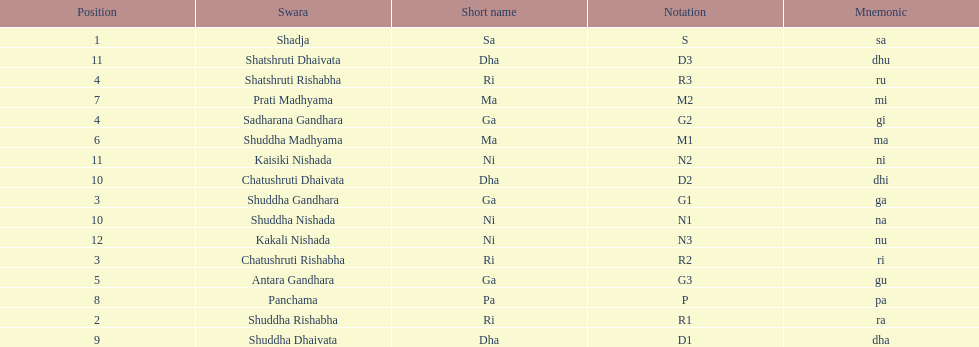List each pair of swaras that share the same position. Chatushruti Rishabha, Shuddha Gandhara, Shatshruti Rishabha, Sadharana Gandhara, Chatushruti Dhaivata, Shuddha Nishada, Shatshruti Dhaivata, Kaisiki Nishada. 